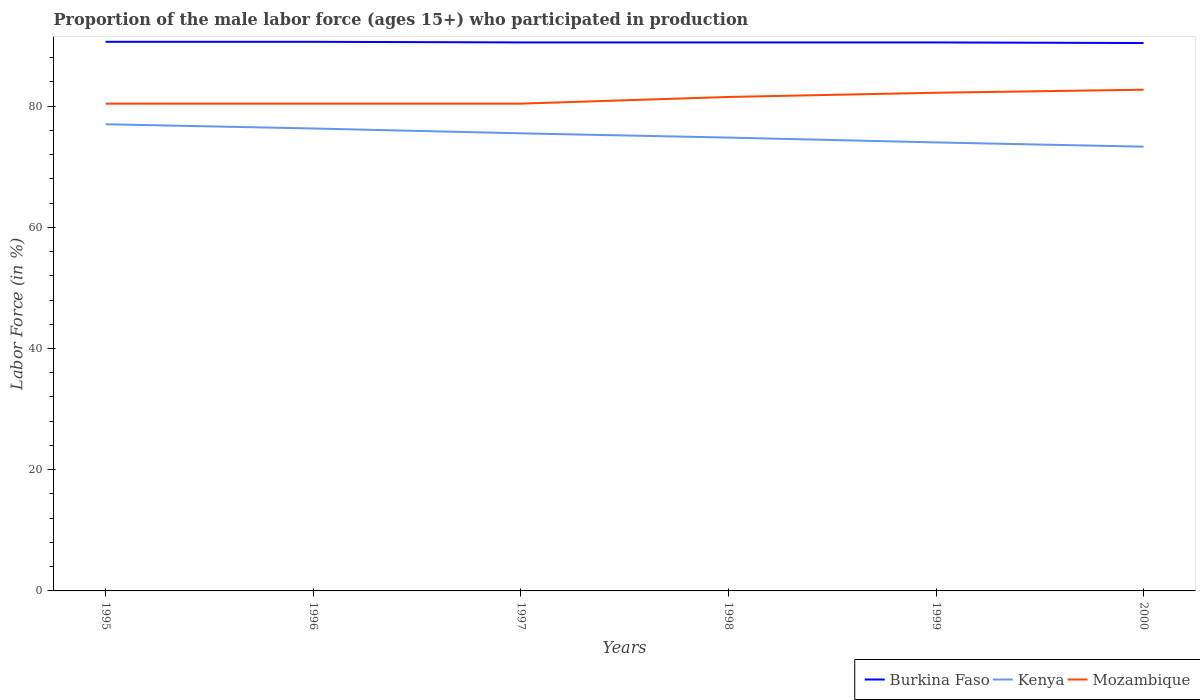Is the number of lines equal to the number of legend labels?
Your response must be concise. Yes. Across all years, what is the maximum proportion of the male labor force who participated in production in Burkina Faso?
Your response must be concise. 90.4. In which year was the proportion of the male labor force who participated in production in Mozambique maximum?
Offer a very short reply. 1995. What is the difference between the highest and the second highest proportion of the male labor force who participated in production in Mozambique?
Keep it short and to the point. 2.3. Is the proportion of the male labor force who participated in production in Burkina Faso strictly greater than the proportion of the male labor force who participated in production in Kenya over the years?
Make the answer very short. No. Are the values on the major ticks of Y-axis written in scientific E-notation?
Provide a succinct answer. No. Does the graph contain any zero values?
Your answer should be compact. No. Does the graph contain grids?
Offer a terse response. No. How are the legend labels stacked?
Provide a short and direct response. Horizontal. What is the title of the graph?
Offer a very short reply. Proportion of the male labor force (ages 15+) who participated in production. Does "Nigeria" appear as one of the legend labels in the graph?
Your answer should be very brief. No. What is the Labor Force (in %) in Burkina Faso in 1995?
Give a very brief answer. 90.6. What is the Labor Force (in %) of Kenya in 1995?
Offer a very short reply. 77. What is the Labor Force (in %) of Mozambique in 1995?
Ensure brevity in your answer.  80.4. What is the Labor Force (in %) in Burkina Faso in 1996?
Ensure brevity in your answer.  90.6. What is the Labor Force (in %) of Kenya in 1996?
Make the answer very short. 76.3. What is the Labor Force (in %) of Mozambique in 1996?
Make the answer very short. 80.4. What is the Labor Force (in %) of Burkina Faso in 1997?
Provide a short and direct response. 90.5. What is the Labor Force (in %) of Kenya in 1997?
Keep it short and to the point. 75.5. What is the Labor Force (in %) in Mozambique in 1997?
Offer a very short reply. 80.4. What is the Labor Force (in %) in Burkina Faso in 1998?
Offer a terse response. 90.5. What is the Labor Force (in %) of Kenya in 1998?
Make the answer very short. 74.8. What is the Labor Force (in %) of Mozambique in 1998?
Ensure brevity in your answer.  81.5. What is the Labor Force (in %) in Burkina Faso in 1999?
Give a very brief answer. 90.5. What is the Labor Force (in %) of Kenya in 1999?
Make the answer very short. 74. What is the Labor Force (in %) in Mozambique in 1999?
Make the answer very short. 82.2. What is the Labor Force (in %) in Burkina Faso in 2000?
Offer a terse response. 90.4. What is the Labor Force (in %) in Kenya in 2000?
Make the answer very short. 73.3. What is the Labor Force (in %) in Mozambique in 2000?
Your response must be concise. 82.7. Across all years, what is the maximum Labor Force (in %) in Burkina Faso?
Keep it short and to the point. 90.6. Across all years, what is the maximum Labor Force (in %) of Kenya?
Your answer should be very brief. 77. Across all years, what is the maximum Labor Force (in %) of Mozambique?
Provide a succinct answer. 82.7. Across all years, what is the minimum Labor Force (in %) of Burkina Faso?
Your answer should be very brief. 90.4. Across all years, what is the minimum Labor Force (in %) in Kenya?
Offer a terse response. 73.3. Across all years, what is the minimum Labor Force (in %) in Mozambique?
Provide a succinct answer. 80.4. What is the total Labor Force (in %) in Burkina Faso in the graph?
Make the answer very short. 543.1. What is the total Labor Force (in %) of Kenya in the graph?
Offer a very short reply. 450.9. What is the total Labor Force (in %) in Mozambique in the graph?
Your response must be concise. 487.6. What is the difference between the Labor Force (in %) in Burkina Faso in 1995 and that in 1996?
Make the answer very short. 0. What is the difference between the Labor Force (in %) of Kenya in 1995 and that in 1996?
Your answer should be compact. 0.7. What is the difference between the Labor Force (in %) in Mozambique in 1995 and that in 1996?
Keep it short and to the point. 0. What is the difference between the Labor Force (in %) in Mozambique in 1995 and that in 1997?
Offer a very short reply. 0. What is the difference between the Labor Force (in %) in Mozambique in 1995 and that in 1998?
Your answer should be very brief. -1.1. What is the difference between the Labor Force (in %) in Burkina Faso in 1995 and that in 1999?
Your answer should be very brief. 0.1. What is the difference between the Labor Force (in %) of Burkina Faso in 1995 and that in 2000?
Keep it short and to the point. 0.2. What is the difference between the Labor Force (in %) of Kenya in 1995 and that in 2000?
Your answer should be very brief. 3.7. What is the difference between the Labor Force (in %) of Mozambique in 1995 and that in 2000?
Your answer should be compact. -2.3. What is the difference between the Labor Force (in %) in Mozambique in 1996 and that in 1998?
Ensure brevity in your answer.  -1.1. What is the difference between the Labor Force (in %) of Mozambique in 1996 and that in 1999?
Ensure brevity in your answer.  -1.8. What is the difference between the Labor Force (in %) of Burkina Faso in 1996 and that in 2000?
Your answer should be compact. 0.2. What is the difference between the Labor Force (in %) in Kenya in 1996 and that in 2000?
Provide a short and direct response. 3. What is the difference between the Labor Force (in %) in Burkina Faso in 1997 and that in 1998?
Your answer should be compact. 0. What is the difference between the Labor Force (in %) of Burkina Faso in 1997 and that in 1999?
Your response must be concise. 0. What is the difference between the Labor Force (in %) in Mozambique in 1997 and that in 1999?
Ensure brevity in your answer.  -1.8. What is the difference between the Labor Force (in %) in Kenya in 1997 and that in 2000?
Provide a short and direct response. 2.2. What is the difference between the Labor Force (in %) in Mozambique in 1997 and that in 2000?
Keep it short and to the point. -2.3. What is the difference between the Labor Force (in %) of Mozambique in 1998 and that in 1999?
Keep it short and to the point. -0.7. What is the difference between the Labor Force (in %) in Kenya in 1998 and that in 2000?
Make the answer very short. 1.5. What is the difference between the Labor Force (in %) of Mozambique in 1998 and that in 2000?
Your answer should be compact. -1.2. What is the difference between the Labor Force (in %) of Burkina Faso in 1999 and that in 2000?
Your answer should be very brief. 0.1. What is the difference between the Labor Force (in %) in Burkina Faso in 1995 and the Labor Force (in %) in Kenya in 1996?
Ensure brevity in your answer.  14.3. What is the difference between the Labor Force (in %) of Burkina Faso in 1995 and the Labor Force (in %) of Mozambique in 1996?
Your answer should be very brief. 10.2. What is the difference between the Labor Force (in %) of Burkina Faso in 1995 and the Labor Force (in %) of Kenya in 1997?
Ensure brevity in your answer.  15.1. What is the difference between the Labor Force (in %) in Burkina Faso in 1995 and the Labor Force (in %) in Mozambique in 1997?
Provide a short and direct response. 10.2. What is the difference between the Labor Force (in %) in Burkina Faso in 1995 and the Labor Force (in %) in Kenya in 1998?
Offer a terse response. 15.8. What is the difference between the Labor Force (in %) of Kenya in 1995 and the Labor Force (in %) of Mozambique in 1999?
Your response must be concise. -5.2. What is the difference between the Labor Force (in %) in Burkina Faso in 1996 and the Labor Force (in %) in Mozambique in 1997?
Make the answer very short. 10.2. What is the difference between the Labor Force (in %) of Burkina Faso in 1996 and the Labor Force (in %) of Kenya in 1998?
Offer a very short reply. 15.8. What is the difference between the Labor Force (in %) of Burkina Faso in 1996 and the Labor Force (in %) of Mozambique in 1999?
Offer a very short reply. 8.4. What is the difference between the Labor Force (in %) of Kenya in 1996 and the Labor Force (in %) of Mozambique in 1999?
Keep it short and to the point. -5.9. What is the difference between the Labor Force (in %) in Burkina Faso in 1996 and the Labor Force (in %) in Mozambique in 2000?
Provide a succinct answer. 7.9. What is the difference between the Labor Force (in %) in Kenya in 1997 and the Labor Force (in %) in Mozambique in 1998?
Provide a succinct answer. -6. What is the difference between the Labor Force (in %) of Burkina Faso in 1997 and the Labor Force (in %) of Kenya in 1999?
Ensure brevity in your answer.  16.5. What is the difference between the Labor Force (in %) in Burkina Faso in 1997 and the Labor Force (in %) in Mozambique in 1999?
Offer a terse response. 8.3. What is the difference between the Labor Force (in %) of Kenya in 1997 and the Labor Force (in %) of Mozambique in 1999?
Ensure brevity in your answer.  -6.7. What is the difference between the Labor Force (in %) in Burkina Faso in 1997 and the Labor Force (in %) in Mozambique in 2000?
Your answer should be very brief. 7.8. What is the difference between the Labor Force (in %) in Burkina Faso in 1998 and the Labor Force (in %) in Mozambique in 1999?
Provide a succinct answer. 8.3. What is the difference between the Labor Force (in %) of Kenya in 1998 and the Labor Force (in %) of Mozambique in 1999?
Your answer should be very brief. -7.4. What is the difference between the Labor Force (in %) of Burkina Faso in 1998 and the Labor Force (in %) of Mozambique in 2000?
Ensure brevity in your answer.  7.8. What is the difference between the Labor Force (in %) of Burkina Faso in 1999 and the Labor Force (in %) of Kenya in 2000?
Provide a succinct answer. 17.2. What is the difference between the Labor Force (in %) in Burkina Faso in 1999 and the Labor Force (in %) in Mozambique in 2000?
Make the answer very short. 7.8. What is the difference between the Labor Force (in %) in Kenya in 1999 and the Labor Force (in %) in Mozambique in 2000?
Provide a succinct answer. -8.7. What is the average Labor Force (in %) of Burkina Faso per year?
Give a very brief answer. 90.52. What is the average Labor Force (in %) of Kenya per year?
Provide a short and direct response. 75.15. What is the average Labor Force (in %) in Mozambique per year?
Your answer should be compact. 81.27. In the year 1995, what is the difference between the Labor Force (in %) in Burkina Faso and Labor Force (in %) in Kenya?
Provide a short and direct response. 13.6. In the year 1995, what is the difference between the Labor Force (in %) in Burkina Faso and Labor Force (in %) in Mozambique?
Provide a succinct answer. 10.2. In the year 1997, what is the difference between the Labor Force (in %) of Burkina Faso and Labor Force (in %) of Mozambique?
Ensure brevity in your answer.  10.1. In the year 1998, what is the difference between the Labor Force (in %) in Burkina Faso and Labor Force (in %) in Kenya?
Give a very brief answer. 15.7. In the year 1999, what is the difference between the Labor Force (in %) in Burkina Faso and Labor Force (in %) in Kenya?
Provide a succinct answer. 16.5. In the year 2000, what is the difference between the Labor Force (in %) in Burkina Faso and Labor Force (in %) in Mozambique?
Ensure brevity in your answer.  7.7. What is the ratio of the Labor Force (in %) in Kenya in 1995 to that in 1996?
Provide a short and direct response. 1.01. What is the ratio of the Labor Force (in %) of Kenya in 1995 to that in 1997?
Make the answer very short. 1.02. What is the ratio of the Labor Force (in %) in Mozambique in 1995 to that in 1997?
Ensure brevity in your answer.  1. What is the ratio of the Labor Force (in %) in Kenya in 1995 to that in 1998?
Give a very brief answer. 1.03. What is the ratio of the Labor Force (in %) in Mozambique in 1995 to that in 1998?
Ensure brevity in your answer.  0.99. What is the ratio of the Labor Force (in %) of Burkina Faso in 1995 to that in 1999?
Keep it short and to the point. 1. What is the ratio of the Labor Force (in %) of Kenya in 1995 to that in 1999?
Your answer should be compact. 1.04. What is the ratio of the Labor Force (in %) in Mozambique in 1995 to that in 1999?
Keep it short and to the point. 0.98. What is the ratio of the Labor Force (in %) in Kenya in 1995 to that in 2000?
Provide a short and direct response. 1.05. What is the ratio of the Labor Force (in %) in Mozambique in 1995 to that in 2000?
Provide a short and direct response. 0.97. What is the ratio of the Labor Force (in %) in Kenya in 1996 to that in 1997?
Give a very brief answer. 1.01. What is the ratio of the Labor Force (in %) in Kenya in 1996 to that in 1998?
Ensure brevity in your answer.  1.02. What is the ratio of the Labor Force (in %) in Mozambique in 1996 to that in 1998?
Keep it short and to the point. 0.99. What is the ratio of the Labor Force (in %) of Kenya in 1996 to that in 1999?
Give a very brief answer. 1.03. What is the ratio of the Labor Force (in %) in Mozambique in 1996 to that in 1999?
Your answer should be compact. 0.98. What is the ratio of the Labor Force (in %) of Kenya in 1996 to that in 2000?
Give a very brief answer. 1.04. What is the ratio of the Labor Force (in %) of Mozambique in 1996 to that in 2000?
Your response must be concise. 0.97. What is the ratio of the Labor Force (in %) of Kenya in 1997 to that in 1998?
Your answer should be compact. 1.01. What is the ratio of the Labor Force (in %) of Mozambique in 1997 to that in 1998?
Make the answer very short. 0.99. What is the ratio of the Labor Force (in %) in Kenya in 1997 to that in 1999?
Provide a succinct answer. 1.02. What is the ratio of the Labor Force (in %) in Mozambique in 1997 to that in 1999?
Make the answer very short. 0.98. What is the ratio of the Labor Force (in %) in Burkina Faso in 1997 to that in 2000?
Provide a short and direct response. 1. What is the ratio of the Labor Force (in %) of Kenya in 1997 to that in 2000?
Your response must be concise. 1.03. What is the ratio of the Labor Force (in %) of Mozambique in 1997 to that in 2000?
Provide a succinct answer. 0.97. What is the ratio of the Labor Force (in %) of Burkina Faso in 1998 to that in 1999?
Your answer should be compact. 1. What is the ratio of the Labor Force (in %) in Kenya in 1998 to that in 1999?
Provide a short and direct response. 1.01. What is the ratio of the Labor Force (in %) in Burkina Faso in 1998 to that in 2000?
Ensure brevity in your answer.  1. What is the ratio of the Labor Force (in %) of Kenya in 1998 to that in 2000?
Offer a very short reply. 1.02. What is the ratio of the Labor Force (in %) of Mozambique in 1998 to that in 2000?
Your answer should be compact. 0.99. What is the ratio of the Labor Force (in %) of Burkina Faso in 1999 to that in 2000?
Your answer should be very brief. 1. What is the ratio of the Labor Force (in %) in Kenya in 1999 to that in 2000?
Make the answer very short. 1.01. What is the difference between the highest and the second highest Labor Force (in %) in Mozambique?
Your response must be concise. 0.5. What is the difference between the highest and the lowest Labor Force (in %) of Burkina Faso?
Your answer should be very brief. 0.2. 